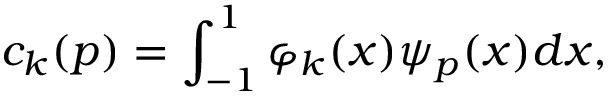<formula> <loc_0><loc_0><loc_500><loc_500>c _ { k } ( p ) = \int _ { - 1 } ^ { 1 } { \varphi } _ { k } ( x ) \psi _ { p } ( x ) d x ,</formula> 